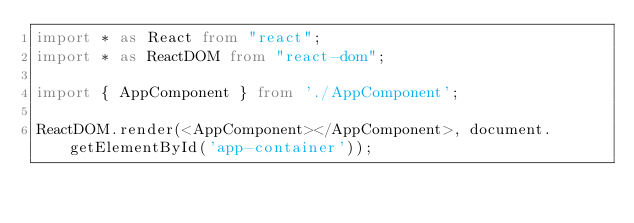Convert code to text. <code><loc_0><loc_0><loc_500><loc_500><_TypeScript_>import * as React from "react";
import * as ReactDOM from "react-dom";

import { AppComponent } from './AppComponent';

ReactDOM.render(<AppComponent></AppComponent>, document.getElementById('app-container'));</code> 